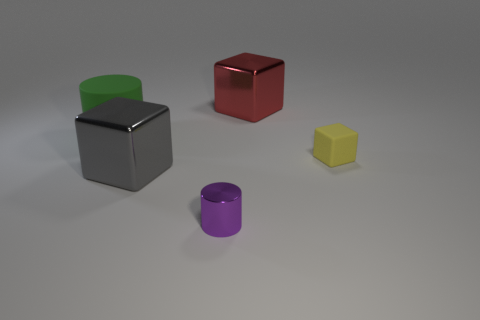Subtract all small yellow blocks. How many blocks are left? 2 Subtract 1 blocks. How many blocks are left? 2 Add 1 large green matte cylinders. How many objects exist? 6 Subtract all cubes. How many objects are left? 2 Add 3 gray cubes. How many gray cubes are left? 4 Add 3 gray blocks. How many gray blocks exist? 4 Subtract 0 cyan blocks. How many objects are left? 5 Subtract all large purple balls. Subtract all metallic cylinders. How many objects are left? 4 